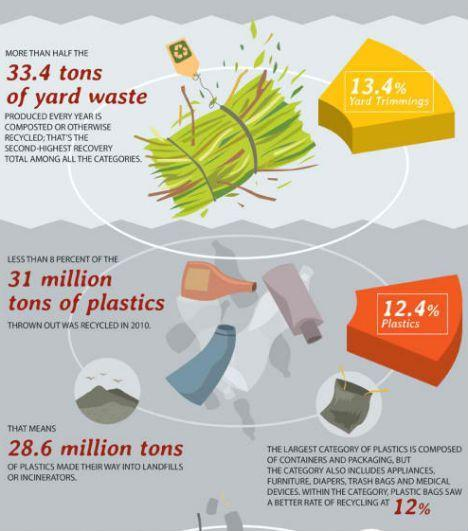How many million tons of plastic were not recycled in 2010, 31, 28.6, or 33.4?
Answer the question with a short phrase. 28.6 What is the percentage of bio waste from yards were recycled, 12%, 12.4%, or 13.4%? 13.4% 